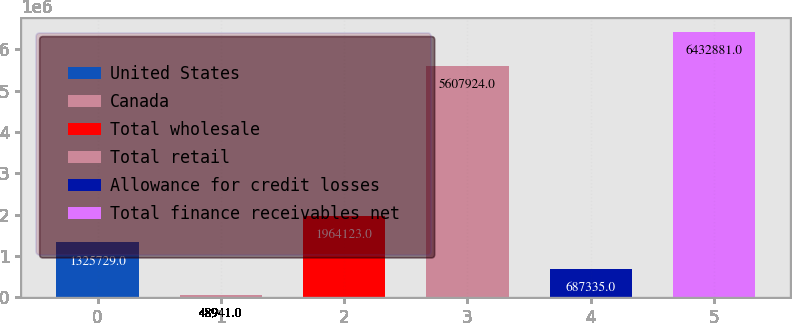Convert chart to OTSL. <chart><loc_0><loc_0><loc_500><loc_500><bar_chart><fcel>United States<fcel>Canada<fcel>Total wholesale<fcel>Total retail<fcel>Allowance for credit losses<fcel>Total finance receivables net<nl><fcel>1.32573e+06<fcel>48941<fcel>1.96412e+06<fcel>5.60792e+06<fcel>687335<fcel>6.43288e+06<nl></chart> 